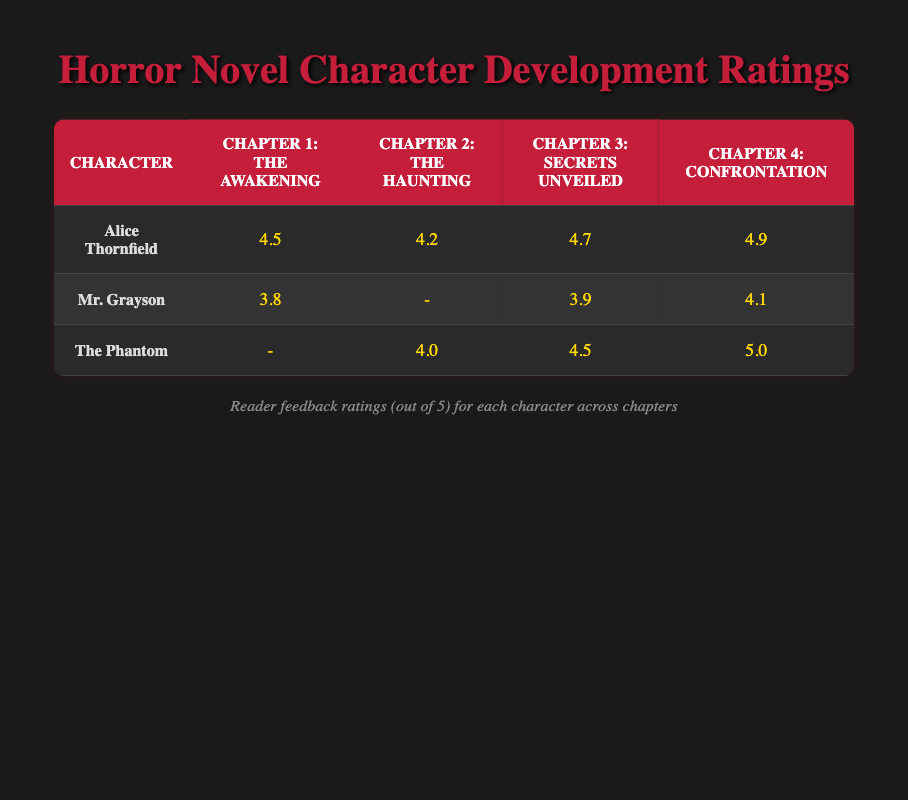What's the reader feedback rating for Alice Thornfield in Chapter 3? The table shows that Alice Thornfield has a rating of 4.7 in Chapter 3, which is straightforwardly retrieved from the cell corresponding to her name and Chapter 3
Answer: 4.7 What is the highest rating achieved by Mr. Grayson across all chapters? By checking the ratings for Mr. Grayson in all chapters provided in the table, we see the ratings are 3.8, - (for Chapter 2), 3.9, and 4.1; thus, the highest rating is 4.1 in Chapter 4
Answer: 4.1 Does The Phantom have ratings in all chapters? Checking the table, The Phantom has ratings in Chapters 2, 3, and 4, but has no rating provided for Chapter 1. Therefore, The Phantom does not have ratings in all chapters
Answer: No What is the average reader feedback rating for Alice Thornfield? To find the average rating for Alice Thornfield, we add her ratings: 4.5 (Chapter 1) + 4.2 (Chapter 2) + 4.7 (Chapter 3) + 4.9 (Chapter 4). The sum is 18.3, and there are 4 chapters, so we divide 18.3 by 4, which gives us 4.575. Rounding this to one decimal place, the average is 4.6
Answer: 4.6 Which character received the lowest rating in Chapter 1? By looking at the ratings in Chapter 1, Alice Thornfield received 4.5, and Mr. Grayson received 3.8. The Phantom does not have a rating listed for Chapter 1, so comparing the values, Mr. Grayson has the lowest rating in Chapter 1
Answer: Mr. Grayson What is the overall trend in Alice Thornfield's ratings across the chapters? Analyzing Alice Thornfield's ratings: 4.5 in Chapter 1, 4.2 in Chapter 2, 4.7 in Chapter 3, and 4.9 in Chapter 4, we can observe that her ratings are generally increasing, indicating an upward trend in reader feedback
Answer: Increasing What is the difference between the highest and lowest ratings for The Phantom? The highest rating for The Phantom is 5.0 in Chapter 4, and the lowest is 4.0 in Chapter 2. The difference is calculated by subtracting the lowest from the highest: 5.0 - 4.0 = 1.0, so the difference is 1.0
Answer: 1.0 